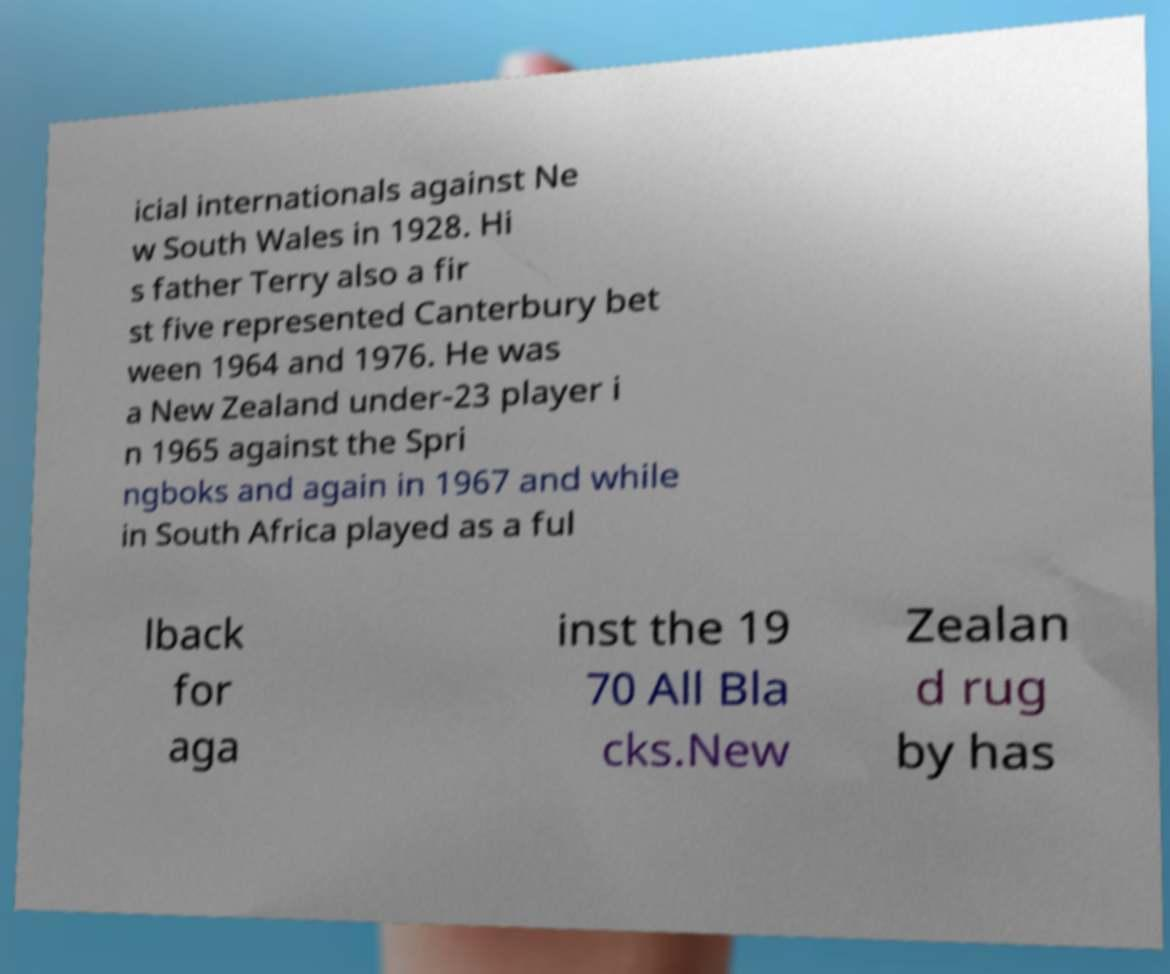Can you read and provide the text displayed in the image?This photo seems to have some interesting text. Can you extract and type it out for me? icial internationals against Ne w South Wales in 1928. Hi s father Terry also a fir st five represented Canterbury bet ween 1964 and 1976. He was a New Zealand under-23 player i n 1965 against the Spri ngboks and again in 1967 and while in South Africa played as a ful lback for aga inst the 19 70 All Bla cks.New Zealan d rug by has 